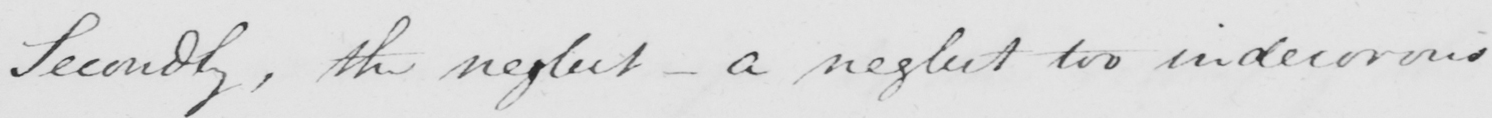Can you tell me what this handwritten text says? Secondly , the neglect  _  a neglect too indecorous 